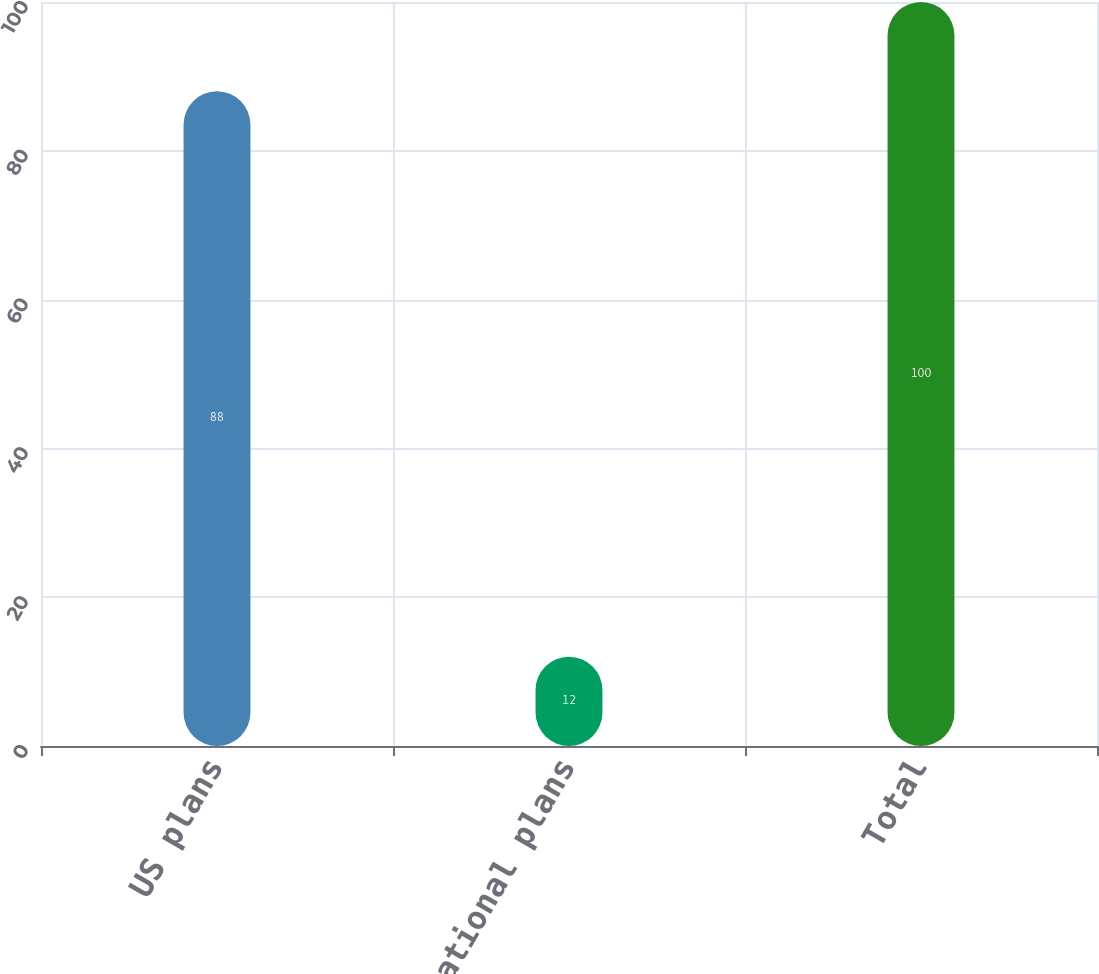Convert chart. <chart><loc_0><loc_0><loc_500><loc_500><bar_chart><fcel>US plans<fcel>International plans<fcel>Total<nl><fcel>88<fcel>12<fcel>100<nl></chart> 